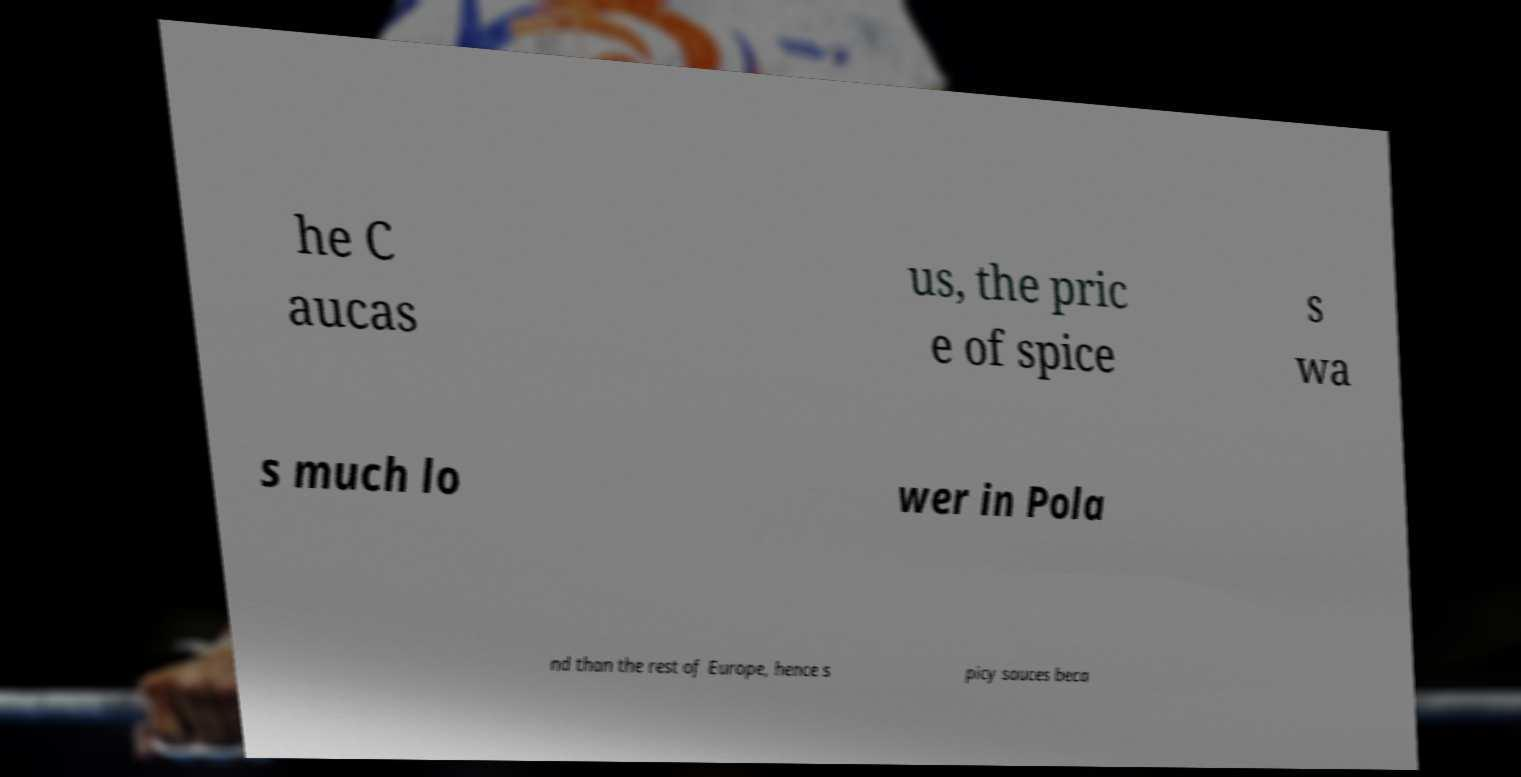Could you extract and type out the text from this image? he C aucas us, the pric e of spice s wa s much lo wer in Pola nd than the rest of Europe, hence s picy sauces beca 